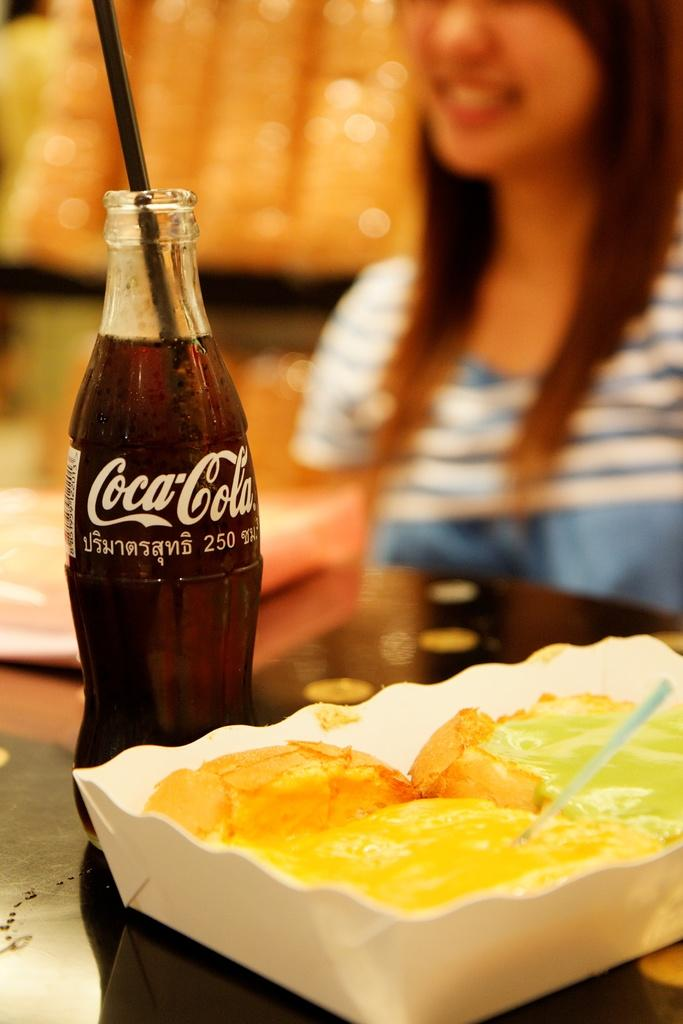Who is present in the image? There is a person in the image. What is the person's expression? The person is smiling. What is the main object in the image besides the person? There is a table in the image. What can be found on the table? There are food items and a Coca-Cola bottle on the table. Can you see a crow's nest on the table in the image? There is no crow's nest present in the image. How does the person's feeling of happiness affect the crow's nest in the image? There is no crow's nest in the image, so it cannot be affected by the person's happiness. 